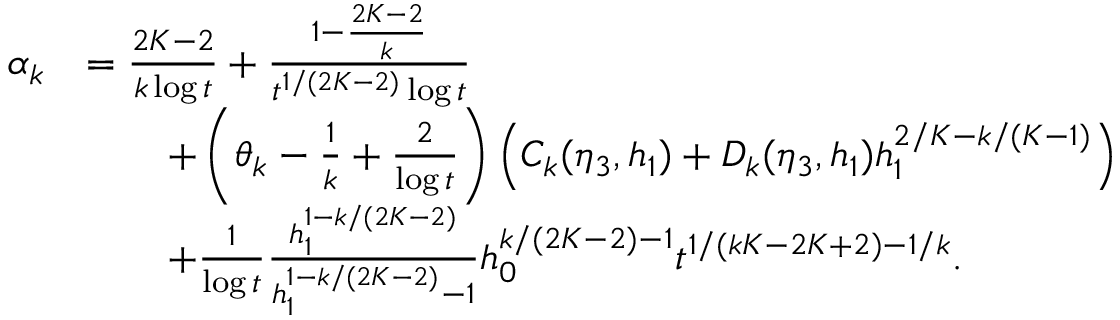Convert formula to latex. <formula><loc_0><loc_0><loc_500><loc_500>\begin{array} { r l } { \alpha _ { k } } & { = \frac { 2 K - 2 } { k \log t } + \frac { 1 - \frac { 2 K - 2 } { k } } { t ^ { 1 / ( 2 K - 2 ) } \log t } } \\ & { \quad + \left ( \theta _ { k } - \frac { 1 } { k } + \frac { 2 } { \log t } \right ) \left ( C _ { k } ( \eta _ { 3 } , h _ { 1 } ) + D _ { k } ( \eta _ { 3 } , h _ { 1 } ) h _ { 1 } ^ { 2 / K - k / ( K - 1 ) } \right ) } \\ & { \quad + \frac { 1 } { \log t } \frac { h _ { 1 } ^ { 1 - k / ( 2 K - 2 ) } } { h _ { 1 } ^ { 1 - k / ( 2 K - 2 ) } - 1 } h _ { 0 } ^ { k / ( 2 K - 2 ) - 1 } t ^ { 1 / ( k K - 2 K + 2 ) - 1 / k } . } \end{array}</formula> 